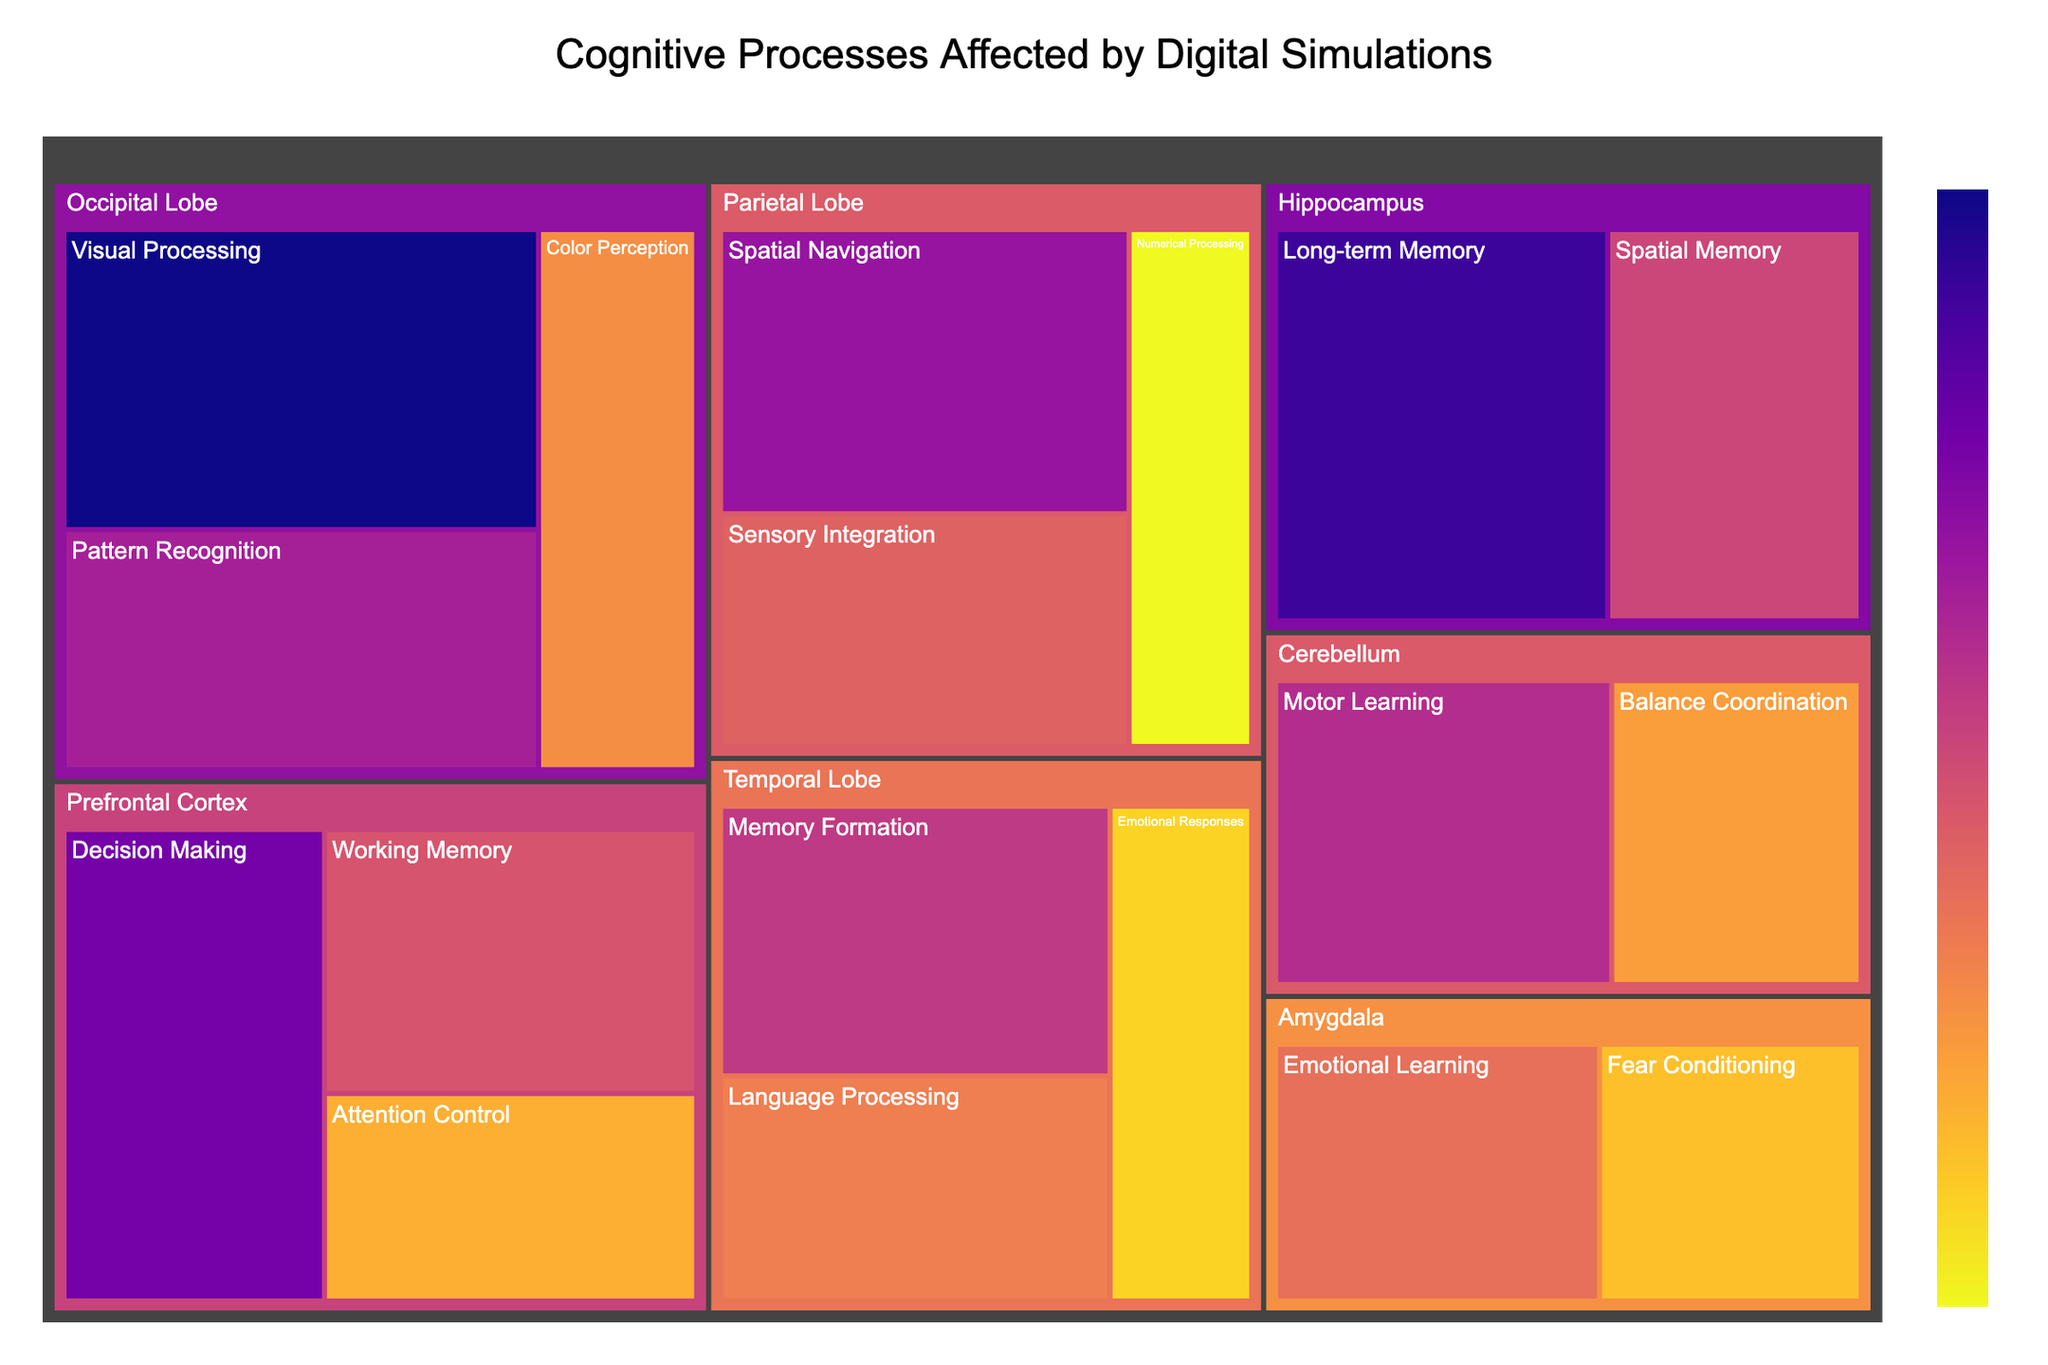What is the title of the treemap? The title is usually found at the top center of the figure. It is a textual description summarizing the figure's content. The title of this treemap is "Cognitive Processes Affected by Digital Simulations".
Answer: Cognitive Processes Affected by Digital Simulations Which cognitive process has the highest impact on the Occipital Lobe? To find this, identify the processes under "Occipital Lobe" and look at their impact values. The process with the highest value is "Visual Processing" with an impact of 40.
Answer: Visual Processing What is the total impact value for the Prefrontal Cortex? Add the impact values of all cognitive processes under "Prefrontal Cortex": Decision Making (35), Working Memory (28), and Attention Control (22). The sum is 35 + 28 + 22 = 85.
Answer: 85 Compare the impact on "Emotional Responses" in the Temporal Lobe to "Fear Conditioning" in the Amygdala. Which has a higher impact? Identify the impact values of "Emotional Responses" in the Temporal Lobe (20) and "Fear Conditioning" in the Amygdala (21). Fear Conditioning has a higher impact.
Answer: Fear Conditioning How does the impact of "Motor Learning" in the Cerebellum compare to "Language Processing" in the Temporal Lobe? Check the impact values: "Motor Learning" in the Cerebellum is 31, while "Language Processing" in the Temporal Lobe is 25. Motor Learning has a higher impact.
Answer: Motor Learning Which brain region is affected most by digital simulations based on the sum of impact values? Sum the impact values for each region. The region with the highest total sum is affected the most. Calculate the sums: Prefrontal Cortex (85), Temporal Lobe (75), Parietal Lobe (78), Occipital Lobe (96), Hippocampus (67), Amygdala (47), Cerebellum (54). Occipital Lobe has the highest sum of 96.
Answer: Occipital Lobe List the cognitive processes and their respective impact values for the Parietal Lobe. Refer to the impact values for each cognitive process under "Parietal Lobe": Spatial Navigation (33), Sensory Integration (27), and Numerical Processing (18).
Answer: Spatial Navigation: 33, Sensory Integration: 27, Numerical Processing: 18 What's the average impact value across all cognitive processes in the Temporal Lobe? Add the impact values of each process in the Temporal Lobe and divide by the number of processes: (30 + 25 + 20) / 3 = 25.
Answer: 25 Identify the brain region with the least overall impact. Sum the impact values for each region and determine the lowest total: Prefrontal Cortex (85), Temporal Lobe (75), Parietal Lobe (78), Occipital Lobe (96), Hippocampus (67), Amygdala (47), Cerebellum (54). The Amygdala has the least overall impact with a total of 47.
Answer: Amygdala 